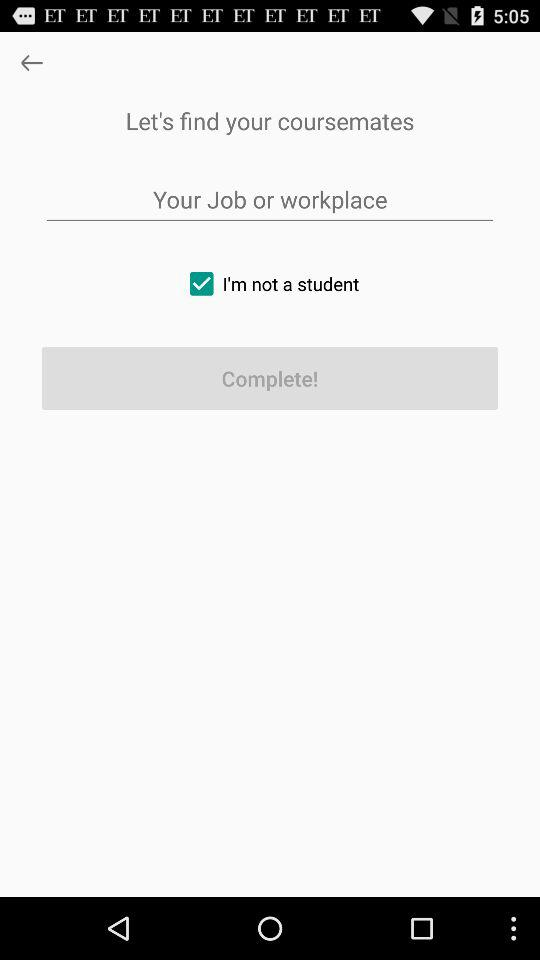What is the status of "I'm not a student"? The status is "on". 